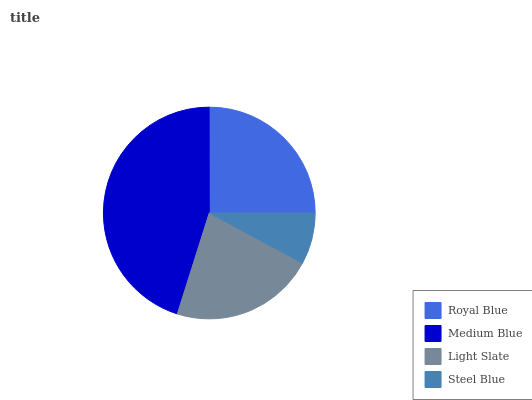Is Steel Blue the minimum?
Answer yes or no. Yes. Is Medium Blue the maximum?
Answer yes or no. Yes. Is Light Slate the minimum?
Answer yes or no. No. Is Light Slate the maximum?
Answer yes or no. No. Is Medium Blue greater than Light Slate?
Answer yes or no. Yes. Is Light Slate less than Medium Blue?
Answer yes or no. Yes. Is Light Slate greater than Medium Blue?
Answer yes or no. No. Is Medium Blue less than Light Slate?
Answer yes or no. No. Is Royal Blue the high median?
Answer yes or no. Yes. Is Light Slate the low median?
Answer yes or no. Yes. Is Light Slate the high median?
Answer yes or no. No. Is Royal Blue the low median?
Answer yes or no. No. 